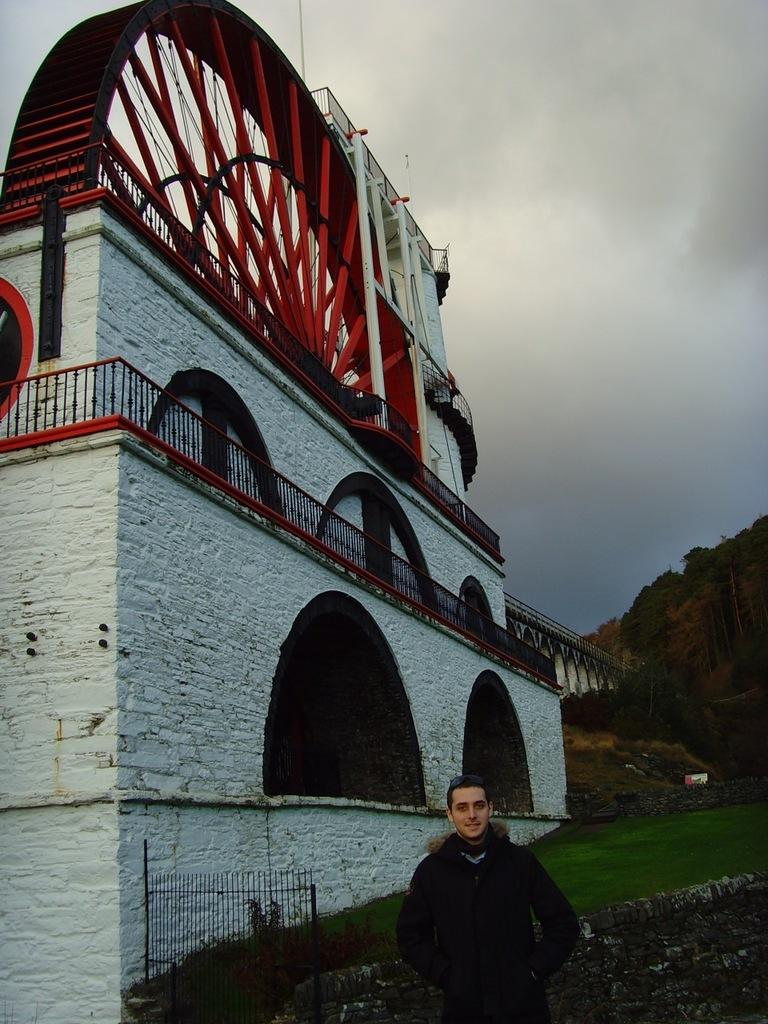Who or what is present in the image? There is a person in the image. What can be seen in the background of the image? There is a wall, a building, fences, grass, a bridge, mountains, and clouds in the sky in the image. What type of bells can be heard ringing in the image? There are no bells present in the image, and therefore no sound can be heard. 